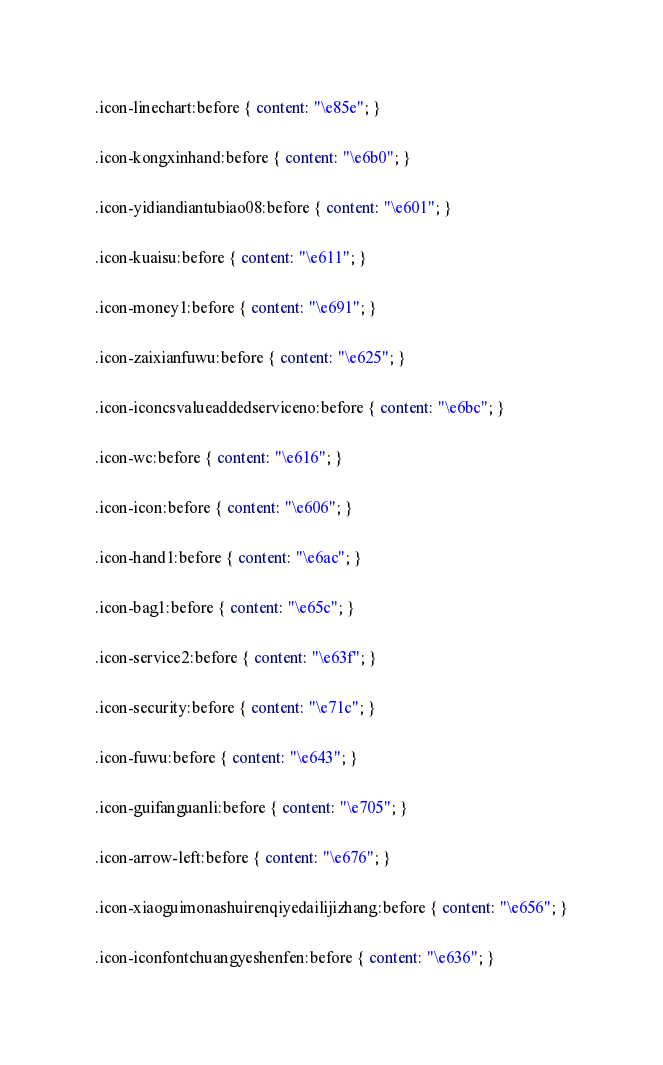Convert code to text. <code><loc_0><loc_0><loc_500><loc_500><_CSS_>.icon-linechart:before { content: "\e85e"; }

.icon-kongxinhand:before { content: "\e6b0"; }

.icon-yidiandiantubiao08:before { content: "\e601"; }

.icon-kuaisu:before { content: "\e611"; }

.icon-money1:before { content: "\e691"; }

.icon-zaixianfuwu:before { content: "\e625"; }

.icon-iconcsvalueaddedserviceno:before { content: "\e6bc"; }

.icon-wc:before { content: "\e616"; }

.icon-icon:before { content: "\e606"; }

.icon-hand1:before { content: "\e6ac"; }

.icon-bag1:before { content: "\e65c"; }

.icon-service2:before { content: "\e63f"; }

.icon-security:before { content: "\e71c"; }

.icon-fuwu:before { content: "\e643"; }

.icon-guifanguanli:before { content: "\e705"; }

.icon-arrow-left:before { content: "\e676"; }

.icon-xiaoguimonashuirenqiyedailijizhang:before { content: "\e656"; }

.icon-iconfontchuangyeshenfen:before { content: "\e636"; }
</code> 